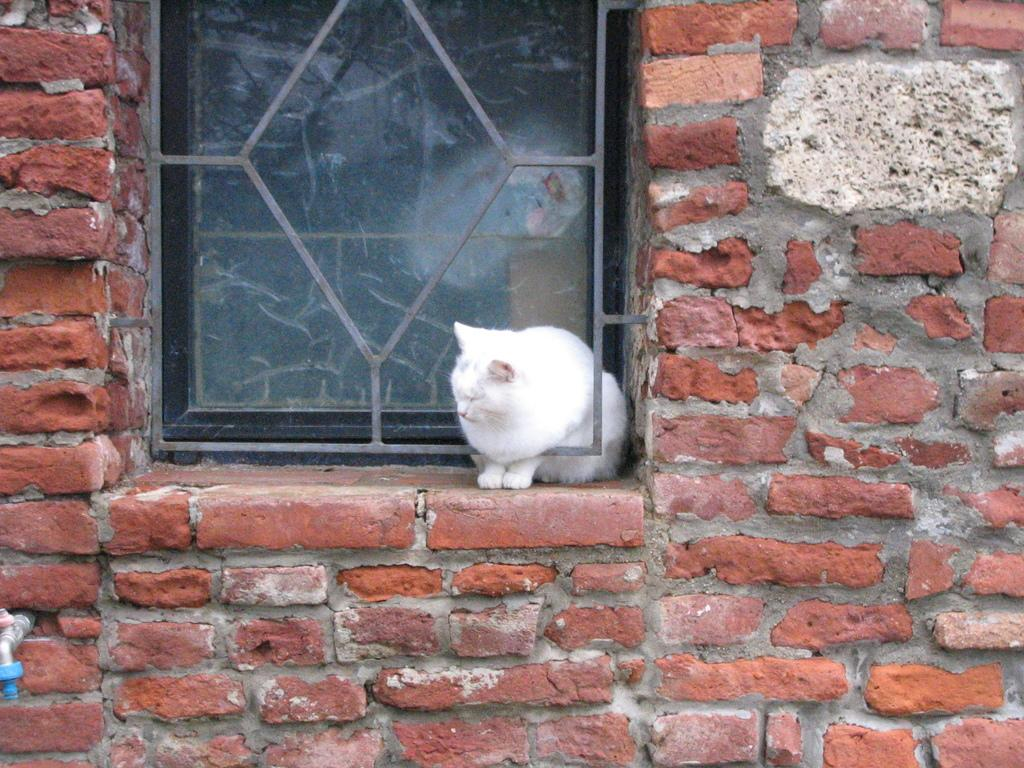What is the main structure in the center of the image? There is a brick wall in the center of the image. What can be seen in the brick wall? There is a window in the image. What is located near the brick wall? There is a tap in the image. What type of animal is present in the image? There is a cat in the image. What is the color of the cat? The cat is white in color. What type of quiver is the cat holding in the image? There is no quiver present in the image; the cat is not holding anything. How many eggs are visible in the image? There are no eggs visible in the image. 